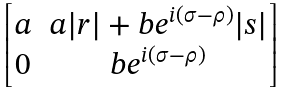<formula> <loc_0><loc_0><loc_500><loc_500>\begin{bmatrix} a & a | r | + b e ^ { i ( \sigma - \rho ) } | s | \\ 0 & b e ^ { i ( \sigma - \rho ) } \end{bmatrix}</formula> 